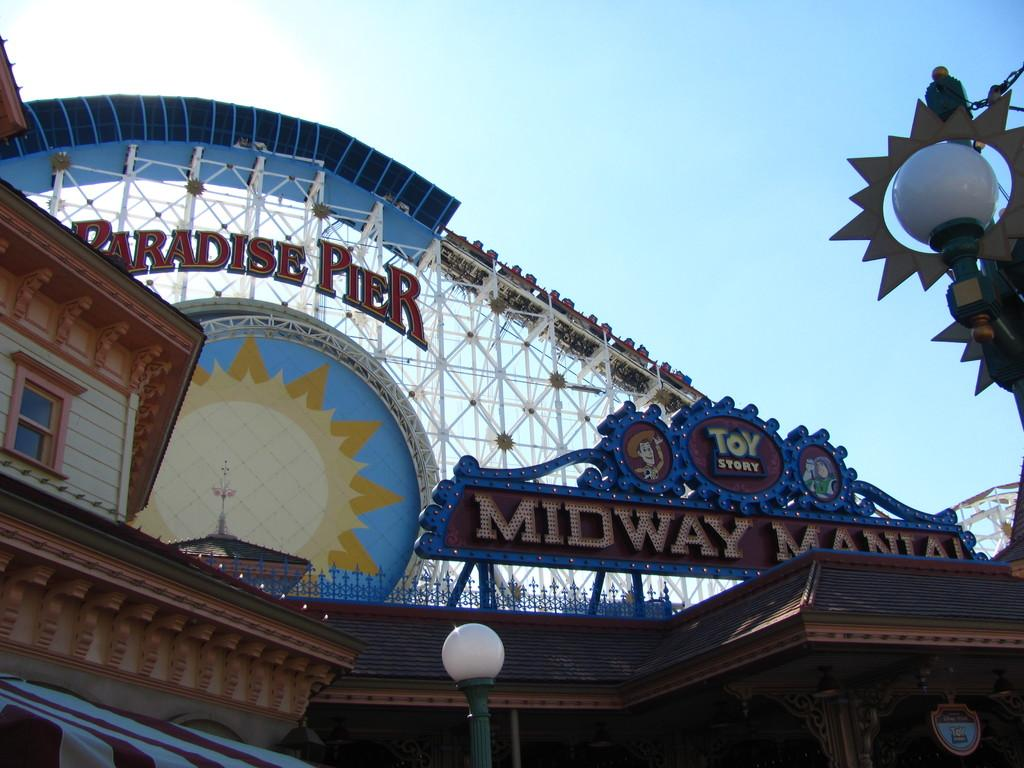<image>
Create a compact narrative representing the image presented. Entrance to a carnival which says Toy Story on it 